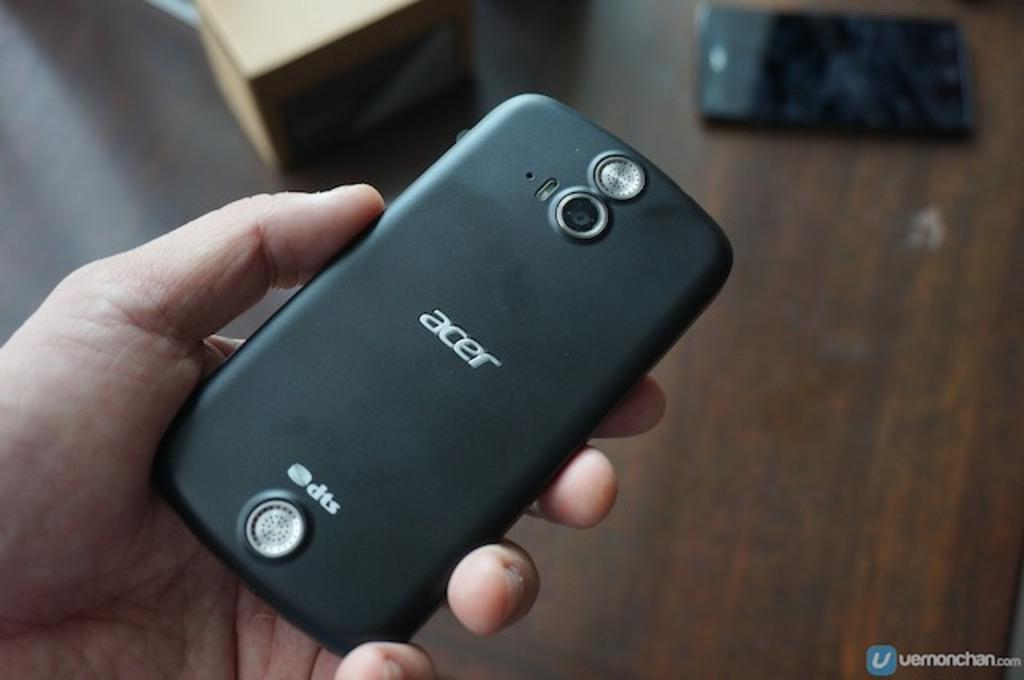<image>
Write a terse but informative summary of the picture. A man is holding a black Acer smart phone. 